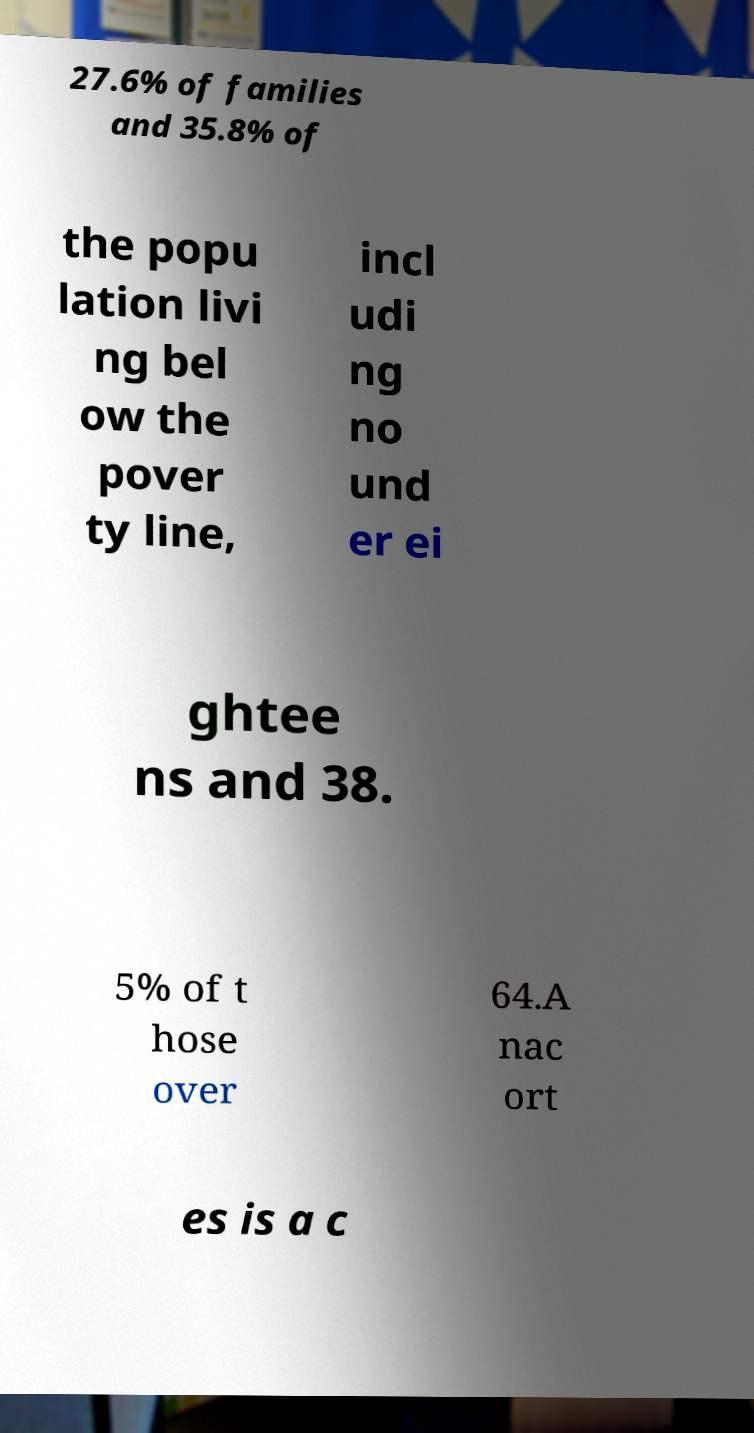Could you extract and type out the text from this image? 27.6% of families and 35.8% of the popu lation livi ng bel ow the pover ty line, incl udi ng no und er ei ghtee ns and 38. 5% of t hose over 64.A nac ort es is a c 